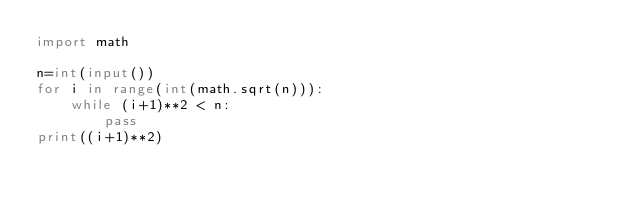Convert code to text. <code><loc_0><loc_0><loc_500><loc_500><_Python_>import math

n=int(input())
for i in range(int(math.sqrt(n))):
    while (i+1)**2 < n:
        pass
print((i+1)**2)</code> 